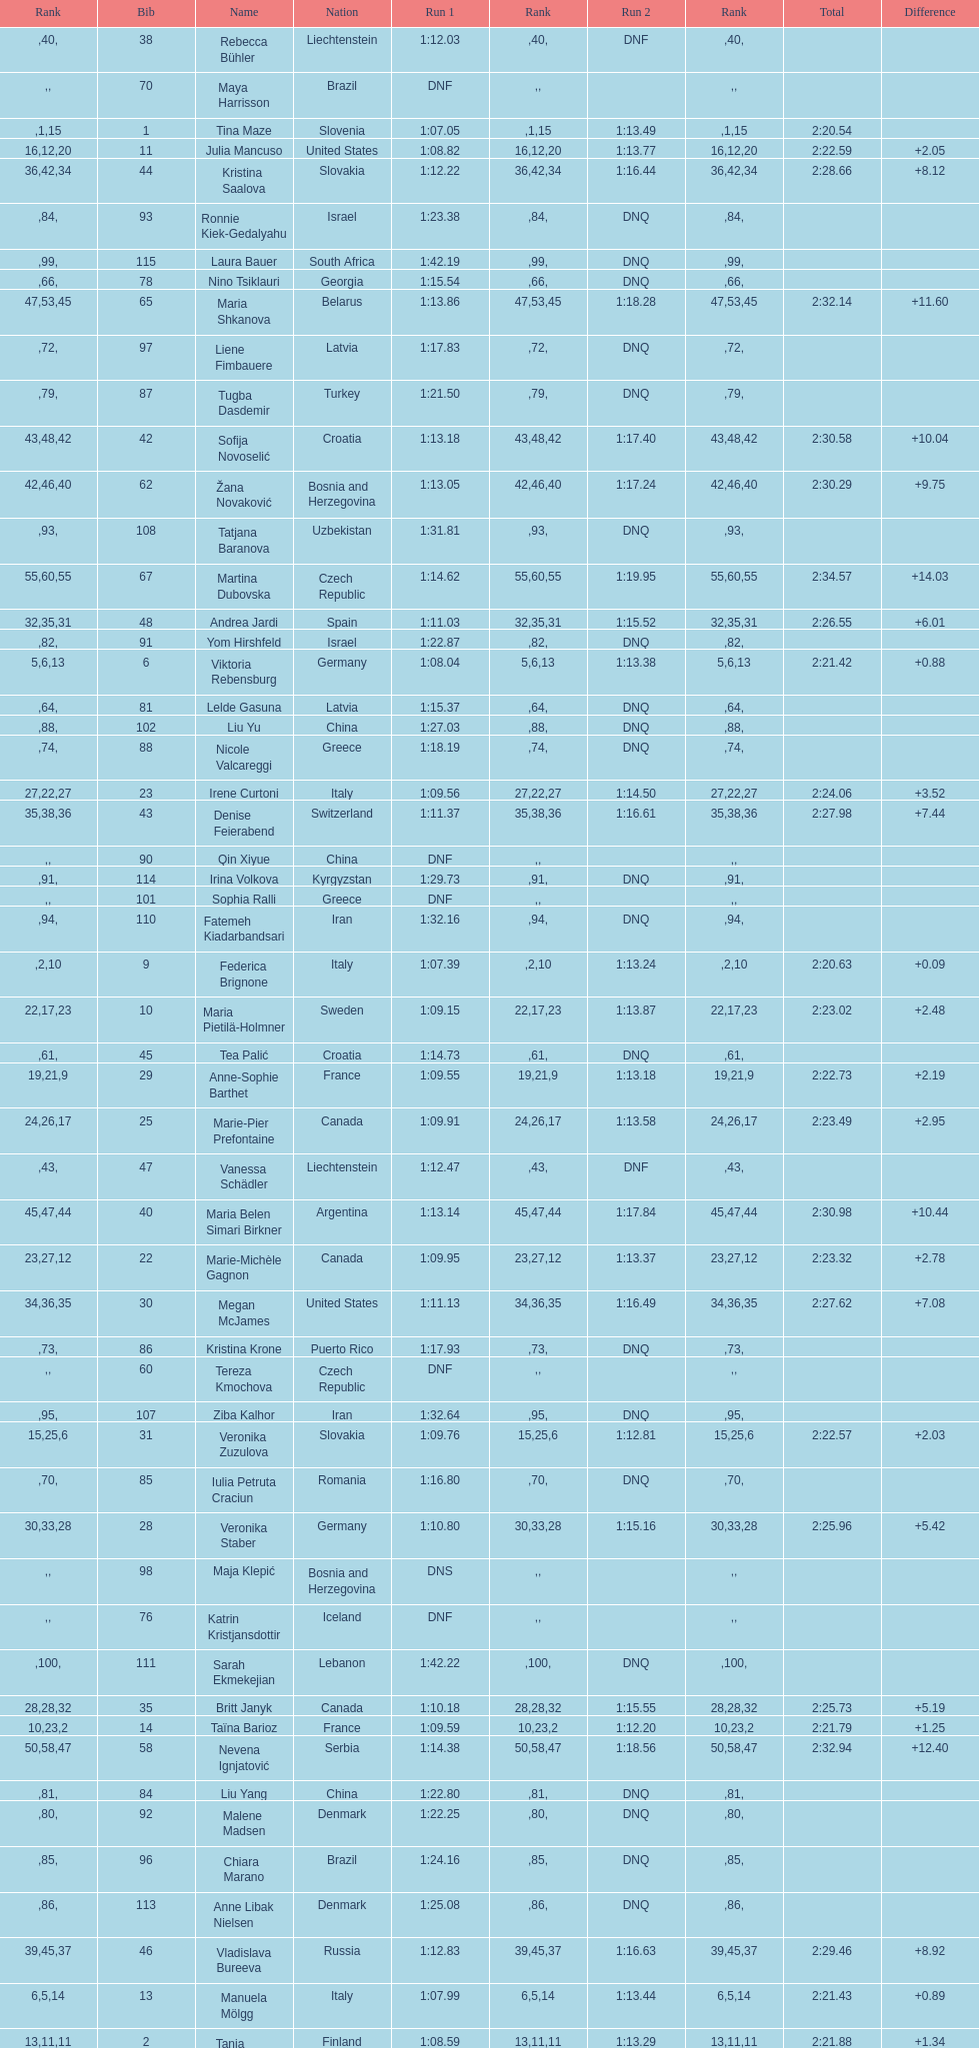How many athletes had the same rank for both run 1 and run 2? 1. 